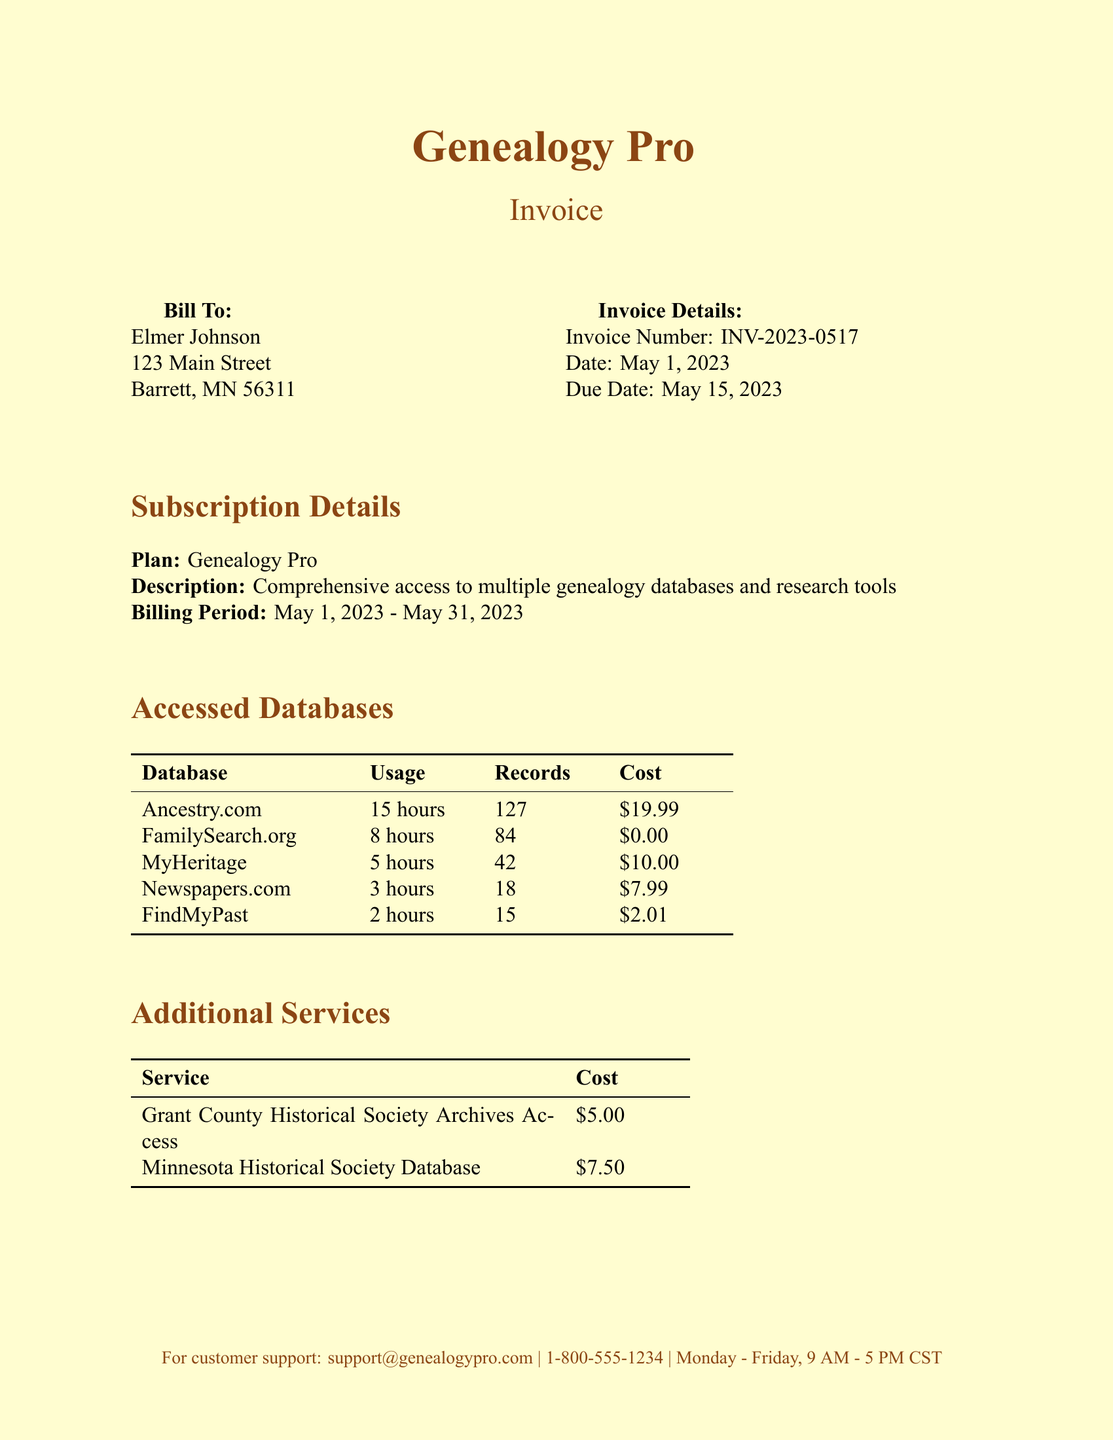What is the customer's name? The name of the customer is specified in the invoice details section.
Answer: Elmer Johnson What is the total amount due? The total amount due is clearly stated in the invoice at the bottom of the document.
Answer: $39.99 What databases were accessed the most? By reviewing the accessed databases, we can identify which had the highest usage.
Answer: Ancestry.com What is the service cost for Grant County Historical Society Archives Access? The cost of this specific additional service is listed in the additional services section of the invoice.
Answer: $5.00 How many hours were spent on FamilySearch.org? The usage hours for each accessed database are included in the breakdown.
Answer: 8 hours What is the billing period for the subscription? The specific dates for the billing period are outlined in the subscription details.
Answer: May 1, 2023 - May 31, 2023 Which payment options are available? The payment options are listed towards the end of the invoice document.
Answer: Credit Card, PayPal What project involves Newspapers.com? By cross-referencing the research projects and the databases used, we find this project.
Answer: Barrett Cooperative Creamery History How many records were accessed from MyHeritage? The number of records accessed is detailed in the accessed databases section.
Answer: 42 